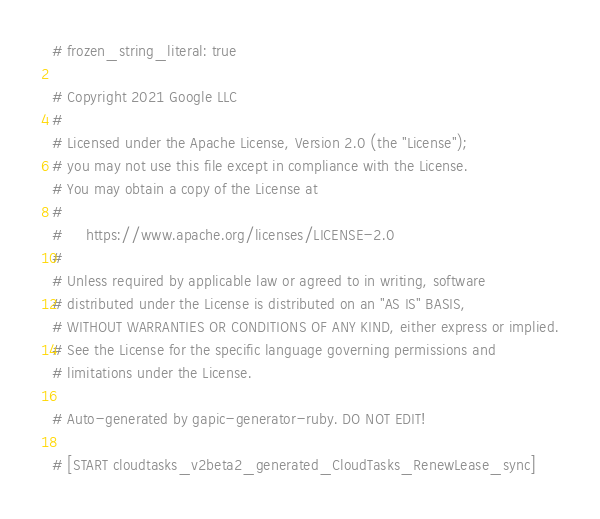Convert code to text. <code><loc_0><loc_0><loc_500><loc_500><_Ruby_># frozen_string_literal: true

# Copyright 2021 Google LLC
#
# Licensed under the Apache License, Version 2.0 (the "License");
# you may not use this file except in compliance with the License.
# You may obtain a copy of the License at
#
#     https://www.apache.org/licenses/LICENSE-2.0
#
# Unless required by applicable law or agreed to in writing, software
# distributed under the License is distributed on an "AS IS" BASIS,
# WITHOUT WARRANTIES OR CONDITIONS OF ANY KIND, either express or implied.
# See the License for the specific language governing permissions and
# limitations under the License.

# Auto-generated by gapic-generator-ruby. DO NOT EDIT!

# [START cloudtasks_v2beta2_generated_CloudTasks_RenewLease_sync]</code> 